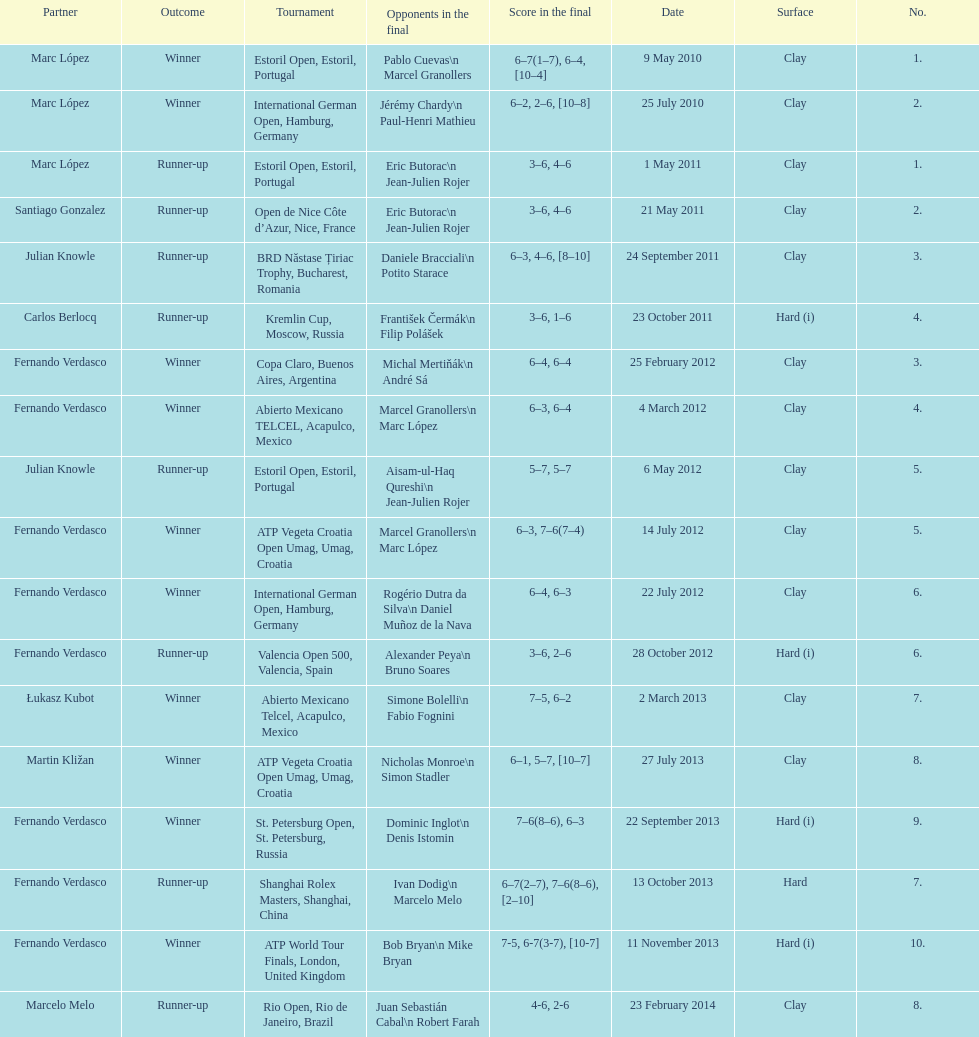How many runner-ups at most are listed? 8. 